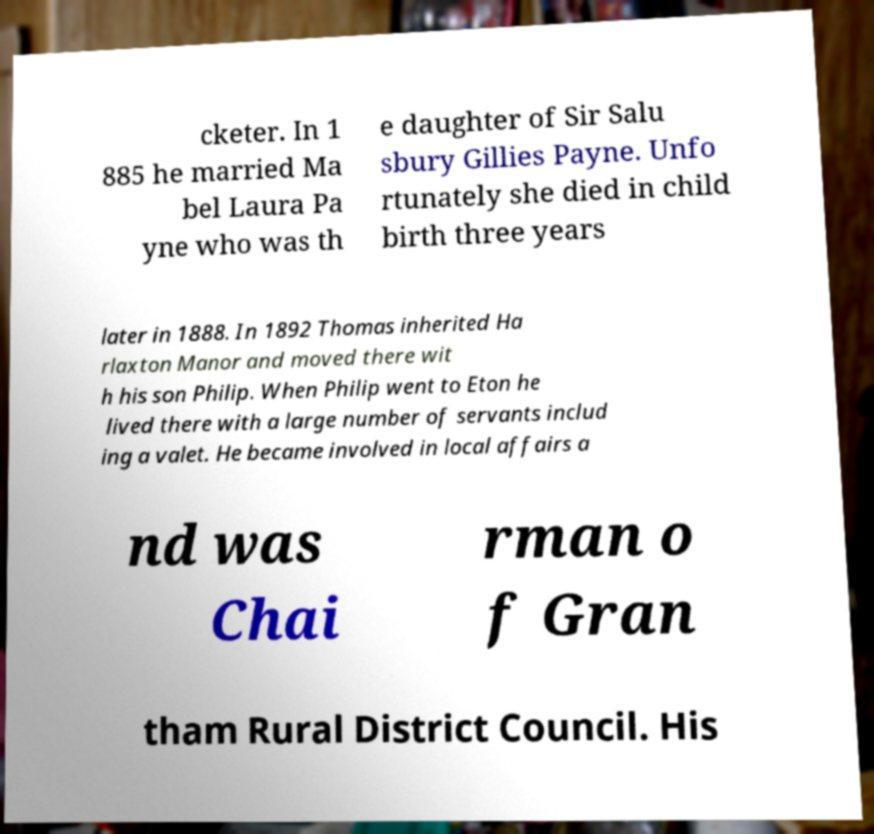Could you assist in decoding the text presented in this image and type it out clearly? cketer. In 1 885 he married Ma bel Laura Pa yne who was th e daughter of Sir Salu sbury Gillies Payne. Unfo rtunately she died in child birth three years later in 1888. In 1892 Thomas inherited Ha rlaxton Manor and moved there wit h his son Philip. When Philip went to Eton he lived there with a large number of servants includ ing a valet. He became involved in local affairs a nd was Chai rman o f Gran tham Rural District Council. His 